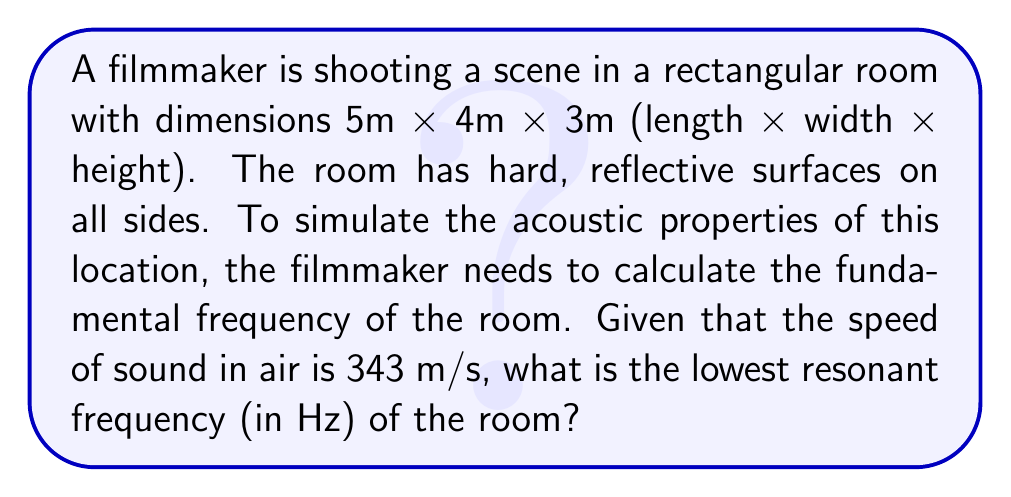Can you answer this question? To solve this problem, we'll use the room mode equation for rectangular spaces:

$$f = \frac{c}{2} \sqrt{\left(\frac{n_x}{L_x}\right)^2 + \left(\frac{n_y}{L_y}\right)^2 + \left(\frac{n_z}{L_z}\right)^2}$$

Where:
$f$ is the resonant frequency
$c$ is the speed of sound in air (343 m/s)
$L_x$, $L_y$, and $L_z$ are the room dimensions
$n_x$, $n_y$, and $n_z$ are mode numbers (integers)

The fundamental frequency (lowest resonant frequency) occurs when $n_x = 1$, $n_y = 0$, and $n_z = 0$.

Step 1: Substitute the values into the equation:
$$f = \frac{343}{2} \sqrt{\left(\frac{1}{5}\right)^2 + \left(\frac{0}{4}\right)^2 + \left(\frac{0}{3}\right)^2}$$

Step 2: Simplify inside the square root:
$$f = \frac{343}{2} \sqrt{0.04 + 0 + 0}$$

Step 3: Calculate:
$$f = \frac{343}{2} \sqrt{0.04} = \frac{343}{2} \times 0.2 = 34.3$$

Therefore, the lowest resonant frequency of the room is approximately 34.3 Hz.
Answer: 34.3 Hz 